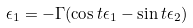<formula> <loc_0><loc_0><loc_500><loc_500>\epsilon _ { 1 } = - \Gamma ( \cos t \epsilon _ { 1 } - \sin t \epsilon _ { 2 } )</formula> 